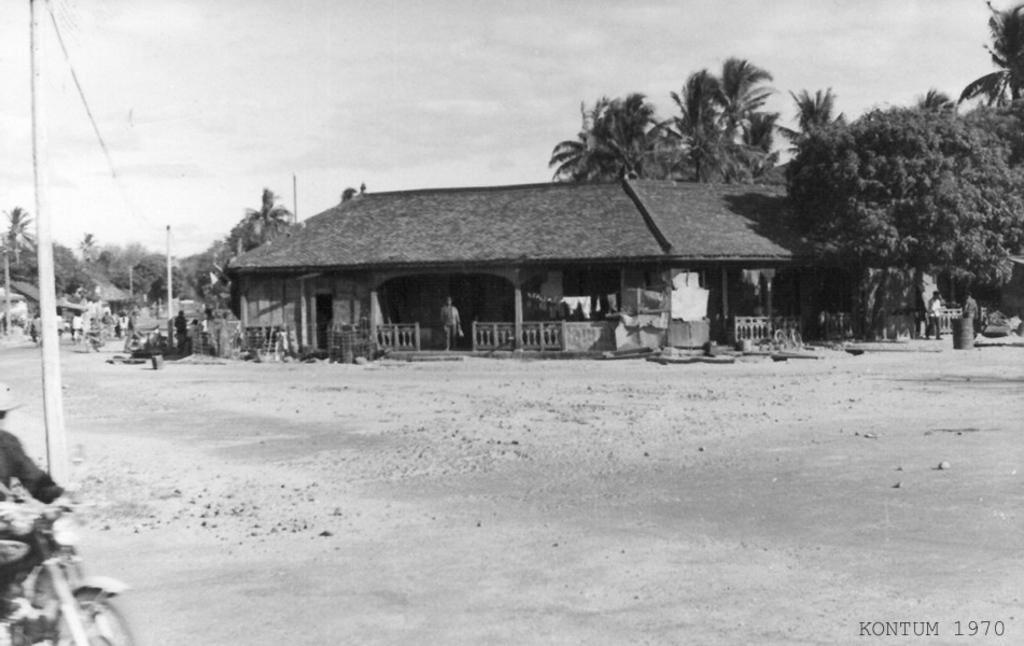How would you summarize this image in a sentence or two? In this image we can see a few people, one of them is riding on the bike, there are plants, trees, there is a barrel, there are houses, poles, also we can see the sky, and there are text and numbers on the image. 